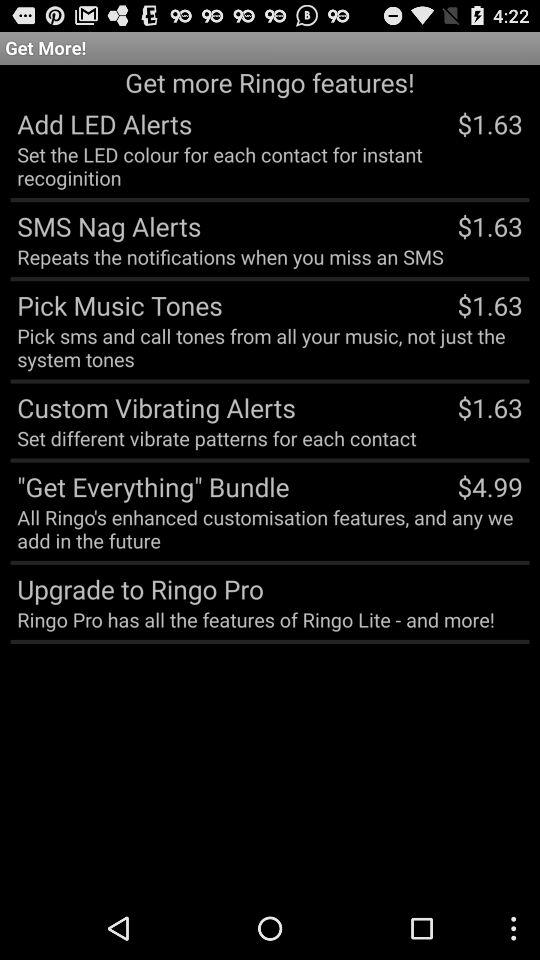How many dollars more expensive is the 'Get Everything' bundle than the Add LED Alerts feature?
Answer the question using a single word or phrase. $3.36 